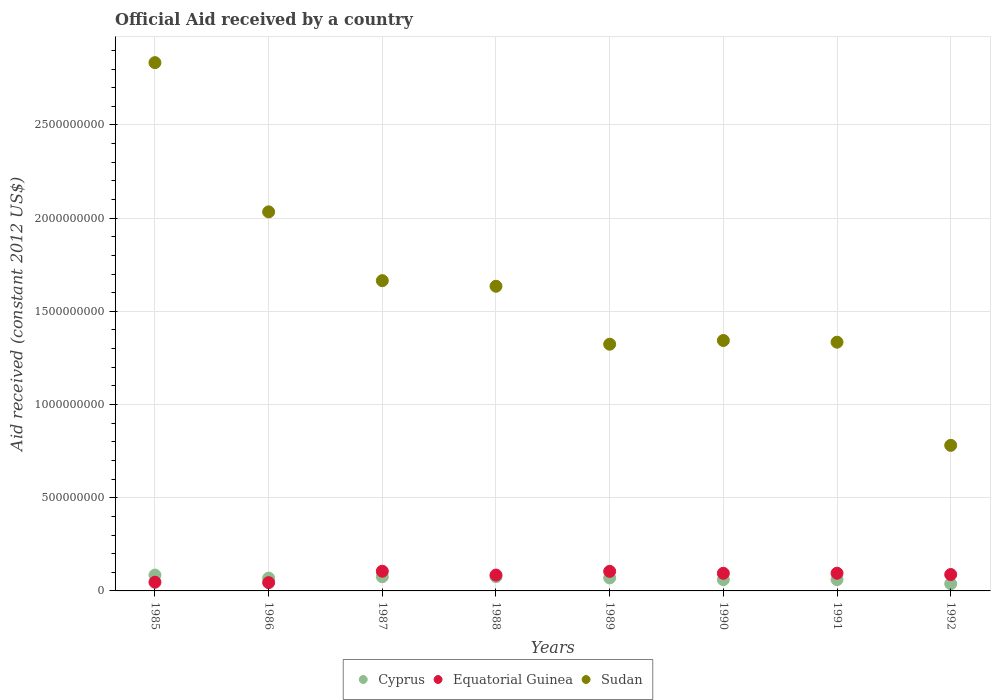What is the net official aid received in Sudan in 1989?
Give a very brief answer. 1.32e+09. Across all years, what is the maximum net official aid received in Equatorial Guinea?
Make the answer very short. 1.06e+08. Across all years, what is the minimum net official aid received in Equatorial Guinea?
Provide a short and direct response. 4.45e+07. In which year was the net official aid received in Cyprus maximum?
Your response must be concise. 1985. In which year was the net official aid received in Equatorial Guinea minimum?
Keep it short and to the point. 1986. What is the total net official aid received in Equatorial Guinea in the graph?
Give a very brief answer. 6.64e+08. What is the difference between the net official aid received in Cyprus in 1987 and that in 1992?
Provide a succinct answer. 3.78e+07. What is the difference between the net official aid received in Cyprus in 1985 and the net official aid received in Sudan in 1992?
Offer a very short reply. -6.96e+08. What is the average net official aid received in Equatorial Guinea per year?
Offer a terse response. 8.31e+07. In the year 1991, what is the difference between the net official aid received in Sudan and net official aid received in Cyprus?
Your response must be concise. 1.27e+09. In how many years, is the net official aid received in Equatorial Guinea greater than 100000000 US$?
Your answer should be very brief. 2. What is the ratio of the net official aid received in Sudan in 1989 to that in 1990?
Offer a terse response. 0.99. What is the difference between the highest and the second highest net official aid received in Equatorial Guinea?
Offer a terse response. 6.80e+05. What is the difference between the highest and the lowest net official aid received in Sudan?
Offer a very short reply. 2.05e+09. In how many years, is the net official aid received in Cyprus greater than the average net official aid received in Cyprus taken over all years?
Provide a succinct answer. 5. Is the sum of the net official aid received in Sudan in 1985 and 1992 greater than the maximum net official aid received in Cyprus across all years?
Your answer should be compact. Yes. Does the net official aid received in Sudan monotonically increase over the years?
Your response must be concise. No. Are the values on the major ticks of Y-axis written in scientific E-notation?
Your response must be concise. No. Does the graph contain any zero values?
Keep it short and to the point. No. Does the graph contain grids?
Your answer should be very brief. Yes. How many legend labels are there?
Offer a very short reply. 3. What is the title of the graph?
Give a very brief answer. Official Aid received by a country. Does "El Salvador" appear as one of the legend labels in the graph?
Offer a terse response. No. What is the label or title of the X-axis?
Keep it short and to the point. Years. What is the label or title of the Y-axis?
Your answer should be compact. Aid received (constant 2012 US$). What is the Aid received (constant 2012 US$) in Cyprus in 1985?
Provide a succinct answer. 8.49e+07. What is the Aid received (constant 2012 US$) of Equatorial Guinea in 1985?
Your response must be concise. 4.67e+07. What is the Aid received (constant 2012 US$) in Sudan in 1985?
Offer a very short reply. 2.83e+09. What is the Aid received (constant 2012 US$) of Cyprus in 1986?
Provide a succinct answer. 6.87e+07. What is the Aid received (constant 2012 US$) of Equatorial Guinea in 1986?
Your response must be concise. 4.45e+07. What is the Aid received (constant 2012 US$) in Sudan in 1986?
Make the answer very short. 2.03e+09. What is the Aid received (constant 2012 US$) of Cyprus in 1987?
Provide a short and direct response. 7.61e+07. What is the Aid received (constant 2012 US$) of Equatorial Guinea in 1987?
Ensure brevity in your answer.  1.06e+08. What is the Aid received (constant 2012 US$) of Sudan in 1987?
Make the answer very short. 1.66e+09. What is the Aid received (constant 2012 US$) of Cyprus in 1988?
Your answer should be very brief. 7.65e+07. What is the Aid received (constant 2012 US$) in Equatorial Guinea in 1988?
Provide a short and direct response. 8.51e+07. What is the Aid received (constant 2012 US$) of Sudan in 1988?
Make the answer very short. 1.63e+09. What is the Aid received (constant 2012 US$) of Cyprus in 1989?
Provide a succinct answer. 6.97e+07. What is the Aid received (constant 2012 US$) in Equatorial Guinea in 1989?
Ensure brevity in your answer.  1.05e+08. What is the Aid received (constant 2012 US$) of Sudan in 1989?
Provide a short and direct response. 1.32e+09. What is the Aid received (constant 2012 US$) in Cyprus in 1990?
Your answer should be compact. 6.04e+07. What is the Aid received (constant 2012 US$) in Equatorial Guinea in 1990?
Offer a very short reply. 9.45e+07. What is the Aid received (constant 2012 US$) in Sudan in 1990?
Your response must be concise. 1.34e+09. What is the Aid received (constant 2012 US$) of Cyprus in 1991?
Provide a succinct answer. 6.07e+07. What is the Aid received (constant 2012 US$) of Equatorial Guinea in 1991?
Make the answer very short. 9.50e+07. What is the Aid received (constant 2012 US$) in Sudan in 1991?
Your response must be concise. 1.33e+09. What is the Aid received (constant 2012 US$) of Cyprus in 1992?
Offer a very short reply. 3.83e+07. What is the Aid received (constant 2012 US$) of Equatorial Guinea in 1992?
Provide a short and direct response. 8.80e+07. What is the Aid received (constant 2012 US$) of Sudan in 1992?
Provide a short and direct response. 7.81e+08. Across all years, what is the maximum Aid received (constant 2012 US$) of Cyprus?
Your answer should be very brief. 8.49e+07. Across all years, what is the maximum Aid received (constant 2012 US$) of Equatorial Guinea?
Provide a succinct answer. 1.06e+08. Across all years, what is the maximum Aid received (constant 2012 US$) in Sudan?
Provide a succinct answer. 2.83e+09. Across all years, what is the minimum Aid received (constant 2012 US$) of Cyprus?
Provide a succinct answer. 3.83e+07. Across all years, what is the minimum Aid received (constant 2012 US$) of Equatorial Guinea?
Make the answer very short. 4.45e+07. Across all years, what is the minimum Aid received (constant 2012 US$) of Sudan?
Provide a short and direct response. 7.81e+08. What is the total Aid received (constant 2012 US$) in Cyprus in the graph?
Your answer should be very brief. 5.35e+08. What is the total Aid received (constant 2012 US$) in Equatorial Guinea in the graph?
Provide a short and direct response. 6.64e+08. What is the total Aid received (constant 2012 US$) of Sudan in the graph?
Make the answer very short. 1.30e+1. What is the difference between the Aid received (constant 2012 US$) in Cyprus in 1985 and that in 1986?
Your answer should be very brief. 1.62e+07. What is the difference between the Aid received (constant 2012 US$) of Equatorial Guinea in 1985 and that in 1986?
Ensure brevity in your answer.  2.23e+06. What is the difference between the Aid received (constant 2012 US$) of Sudan in 1985 and that in 1986?
Your answer should be compact. 8.01e+08. What is the difference between the Aid received (constant 2012 US$) in Cyprus in 1985 and that in 1987?
Make the answer very short. 8.87e+06. What is the difference between the Aid received (constant 2012 US$) in Equatorial Guinea in 1985 and that in 1987?
Offer a very short reply. -5.89e+07. What is the difference between the Aid received (constant 2012 US$) in Sudan in 1985 and that in 1987?
Your answer should be very brief. 1.17e+09. What is the difference between the Aid received (constant 2012 US$) in Cyprus in 1985 and that in 1988?
Offer a very short reply. 8.47e+06. What is the difference between the Aid received (constant 2012 US$) of Equatorial Guinea in 1985 and that in 1988?
Give a very brief answer. -3.84e+07. What is the difference between the Aid received (constant 2012 US$) in Sudan in 1985 and that in 1988?
Make the answer very short. 1.20e+09. What is the difference between the Aid received (constant 2012 US$) in Cyprus in 1985 and that in 1989?
Your answer should be very brief. 1.52e+07. What is the difference between the Aid received (constant 2012 US$) in Equatorial Guinea in 1985 and that in 1989?
Provide a short and direct response. -5.82e+07. What is the difference between the Aid received (constant 2012 US$) in Sudan in 1985 and that in 1989?
Keep it short and to the point. 1.51e+09. What is the difference between the Aid received (constant 2012 US$) of Cyprus in 1985 and that in 1990?
Your answer should be very brief. 2.46e+07. What is the difference between the Aid received (constant 2012 US$) in Equatorial Guinea in 1985 and that in 1990?
Keep it short and to the point. -4.78e+07. What is the difference between the Aid received (constant 2012 US$) in Sudan in 1985 and that in 1990?
Provide a short and direct response. 1.49e+09. What is the difference between the Aid received (constant 2012 US$) of Cyprus in 1985 and that in 1991?
Offer a very short reply. 2.42e+07. What is the difference between the Aid received (constant 2012 US$) in Equatorial Guinea in 1985 and that in 1991?
Provide a succinct answer. -4.83e+07. What is the difference between the Aid received (constant 2012 US$) of Sudan in 1985 and that in 1991?
Provide a short and direct response. 1.50e+09. What is the difference between the Aid received (constant 2012 US$) of Cyprus in 1985 and that in 1992?
Keep it short and to the point. 4.67e+07. What is the difference between the Aid received (constant 2012 US$) of Equatorial Guinea in 1985 and that in 1992?
Your answer should be compact. -4.13e+07. What is the difference between the Aid received (constant 2012 US$) in Sudan in 1985 and that in 1992?
Ensure brevity in your answer.  2.05e+09. What is the difference between the Aid received (constant 2012 US$) of Cyprus in 1986 and that in 1987?
Your answer should be compact. -7.34e+06. What is the difference between the Aid received (constant 2012 US$) in Equatorial Guinea in 1986 and that in 1987?
Keep it short and to the point. -6.11e+07. What is the difference between the Aid received (constant 2012 US$) in Sudan in 1986 and that in 1987?
Offer a very short reply. 3.69e+08. What is the difference between the Aid received (constant 2012 US$) in Cyprus in 1986 and that in 1988?
Your answer should be very brief. -7.74e+06. What is the difference between the Aid received (constant 2012 US$) of Equatorial Guinea in 1986 and that in 1988?
Provide a short and direct response. -4.06e+07. What is the difference between the Aid received (constant 2012 US$) of Sudan in 1986 and that in 1988?
Your response must be concise. 3.99e+08. What is the difference between the Aid received (constant 2012 US$) of Cyprus in 1986 and that in 1989?
Offer a very short reply. -9.90e+05. What is the difference between the Aid received (constant 2012 US$) of Equatorial Guinea in 1986 and that in 1989?
Keep it short and to the point. -6.05e+07. What is the difference between the Aid received (constant 2012 US$) in Sudan in 1986 and that in 1989?
Keep it short and to the point. 7.10e+08. What is the difference between the Aid received (constant 2012 US$) of Cyprus in 1986 and that in 1990?
Ensure brevity in your answer.  8.35e+06. What is the difference between the Aid received (constant 2012 US$) in Equatorial Guinea in 1986 and that in 1990?
Give a very brief answer. -5.00e+07. What is the difference between the Aid received (constant 2012 US$) in Sudan in 1986 and that in 1990?
Your answer should be compact. 6.90e+08. What is the difference between the Aid received (constant 2012 US$) of Cyprus in 1986 and that in 1991?
Ensure brevity in your answer.  8.02e+06. What is the difference between the Aid received (constant 2012 US$) of Equatorial Guinea in 1986 and that in 1991?
Your answer should be compact. -5.05e+07. What is the difference between the Aid received (constant 2012 US$) of Sudan in 1986 and that in 1991?
Your answer should be compact. 6.99e+08. What is the difference between the Aid received (constant 2012 US$) in Cyprus in 1986 and that in 1992?
Your response must be concise. 3.05e+07. What is the difference between the Aid received (constant 2012 US$) of Equatorial Guinea in 1986 and that in 1992?
Your response must be concise. -4.35e+07. What is the difference between the Aid received (constant 2012 US$) of Sudan in 1986 and that in 1992?
Provide a succinct answer. 1.25e+09. What is the difference between the Aid received (constant 2012 US$) in Cyprus in 1987 and that in 1988?
Ensure brevity in your answer.  -4.00e+05. What is the difference between the Aid received (constant 2012 US$) in Equatorial Guinea in 1987 and that in 1988?
Ensure brevity in your answer.  2.05e+07. What is the difference between the Aid received (constant 2012 US$) of Sudan in 1987 and that in 1988?
Provide a short and direct response. 3.00e+07. What is the difference between the Aid received (constant 2012 US$) in Cyprus in 1987 and that in 1989?
Offer a very short reply. 6.35e+06. What is the difference between the Aid received (constant 2012 US$) in Equatorial Guinea in 1987 and that in 1989?
Your response must be concise. 6.80e+05. What is the difference between the Aid received (constant 2012 US$) of Sudan in 1987 and that in 1989?
Make the answer very short. 3.41e+08. What is the difference between the Aid received (constant 2012 US$) of Cyprus in 1987 and that in 1990?
Provide a succinct answer. 1.57e+07. What is the difference between the Aid received (constant 2012 US$) in Equatorial Guinea in 1987 and that in 1990?
Provide a short and direct response. 1.11e+07. What is the difference between the Aid received (constant 2012 US$) in Sudan in 1987 and that in 1990?
Provide a short and direct response. 3.21e+08. What is the difference between the Aid received (constant 2012 US$) of Cyprus in 1987 and that in 1991?
Your answer should be compact. 1.54e+07. What is the difference between the Aid received (constant 2012 US$) of Equatorial Guinea in 1987 and that in 1991?
Provide a short and direct response. 1.06e+07. What is the difference between the Aid received (constant 2012 US$) in Sudan in 1987 and that in 1991?
Offer a very short reply. 3.30e+08. What is the difference between the Aid received (constant 2012 US$) of Cyprus in 1987 and that in 1992?
Offer a terse response. 3.78e+07. What is the difference between the Aid received (constant 2012 US$) of Equatorial Guinea in 1987 and that in 1992?
Offer a terse response. 1.76e+07. What is the difference between the Aid received (constant 2012 US$) of Sudan in 1987 and that in 1992?
Your answer should be very brief. 8.84e+08. What is the difference between the Aid received (constant 2012 US$) in Cyprus in 1988 and that in 1989?
Offer a terse response. 6.75e+06. What is the difference between the Aid received (constant 2012 US$) of Equatorial Guinea in 1988 and that in 1989?
Offer a terse response. -1.98e+07. What is the difference between the Aid received (constant 2012 US$) of Sudan in 1988 and that in 1989?
Provide a short and direct response. 3.11e+08. What is the difference between the Aid received (constant 2012 US$) of Cyprus in 1988 and that in 1990?
Give a very brief answer. 1.61e+07. What is the difference between the Aid received (constant 2012 US$) in Equatorial Guinea in 1988 and that in 1990?
Offer a terse response. -9.40e+06. What is the difference between the Aid received (constant 2012 US$) of Sudan in 1988 and that in 1990?
Make the answer very short. 2.91e+08. What is the difference between the Aid received (constant 2012 US$) of Cyprus in 1988 and that in 1991?
Provide a succinct answer. 1.58e+07. What is the difference between the Aid received (constant 2012 US$) of Equatorial Guinea in 1988 and that in 1991?
Make the answer very short. -9.92e+06. What is the difference between the Aid received (constant 2012 US$) in Sudan in 1988 and that in 1991?
Your answer should be compact. 3.00e+08. What is the difference between the Aid received (constant 2012 US$) of Cyprus in 1988 and that in 1992?
Make the answer very short. 3.82e+07. What is the difference between the Aid received (constant 2012 US$) in Equatorial Guinea in 1988 and that in 1992?
Give a very brief answer. -2.87e+06. What is the difference between the Aid received (constant 2012 US$) in Sudan in 1988 and that in 1992?
Your response must be concise. 8.54e+08. What is the difference between the Aid received (constant 2012 US$) in Cyprus in 1989 and that in 1990?
Offer a terse response. 9.34e+06. What is the difference between the Aid received (constant 2012 US$) of Equatorial Guinea in 1989 and that in 1990?
Ensure brevity in your answer.  1.04e+07. What is the difference between the Aid received (constant 2012 US$) in Sudan in 1989 and that in 1990?
Your answer should be compact. -2.00e+07. What is the difference between the Aid received (constant 2012 US$) in Cyprus in 1989 and that in 1991?
Give a very brief answer. 9.01e+06. What is the difference between the Aid received (constant 2012 US$) of Equatorial Guinea in 1989 and that in 1991?
Give a very brief answer. 9.92e+06. What is the difference between the Aid received (constant 2012 US$) of Sudan in 1989 and that in 1991?
Offer a terse response. -1.09e+07. What is the difference between the Aid received (constant 2012 US$) in Cyprus in 1989 and that in 1992?
Give a very brief answer. 3.14e+07. What is the difference between the Aid received (constant 2012 US$) of Equatorial Guinea in 1989 and that in 1992?
Your response must be concise. 1.70e+07. What is the difference between the Aid received (constant 2012 US$) in Sudan in 1989 and that in 1992?
Your answer should be very brief. 5.43e+08. What is the difference between the Aid received (constant 2012 US$) of Cyprus in 1990 and that in 1991?
Offer a very short reply. -3.30e+05. What is the difference between the Aid received (constant 2012 US$) in Equatorial Guinea in 1990 and that in 1991?
Your response must be concise. -5.20e+05. What is the difference between the Aid received (constant 2012 US$) in Sudan in 1990 and that in 1991?
Provide a succinct answer. 9.13e+06. What is the difference between the Aid received (constant 2012 US$) of Cyprus in 1990 and that in 1992?
Offer a very short reply. 2.21e+07. What is the difference between the Aid received (constant 2012 US$) in Equatorial Guinea in 1990 and that in 1992?
Your answer should be compact. 6.53e+06. What is the difference between the Aid received (constant 2012 US$) of Sudan in 1990 and that in 1992?
Your response must be concise. 5.63e+08. What is the difference between the Aid received (constant 2012 US$) in Cyprus in 1991 and that in 1992?
Offer a very short reply. 2.24e+07. What is the difference between the Aid received (constant 2012 US$) in Equatorial Guinea in 1991 and that in 1992?
Offer a very short reply. 7.05e+06. What is the difference between the Aid received (constant 2012 US$) in Sudan in 1991 and that in 1992?
Offer a terse response. 5.53e+08. What is the difference between the Aid received (constant 2012 US$) of Cyprus in 1985 and the Aid received (constant 2012 US$) of Equatorial Guinea in 1986?
Your answer should be compact. 4.04e+07. What is the difference between the Aid received (constant 2012 US$) of Cyprus in 1985 and the Aid received (constant 2012 US$) of Sudan in 1986?
Your answer should be compact. -1.95e+09. What is the difference between the Aid received (constant 2012 US$) in Equatorial Guinea in 1985 and the Aid received (constant 2012 US$) in Sudan in 1986?
Give a very brief answer. -1.99e+09. What is the difference between the Aid received (constant 2012 US$) in Cyprus in 1985 and the Aid received (constant 2012 US$) in Equatorial Guinea in 1987?
Ensure brevity in your answer.  -2.07e+07. What is the difference between the Aid received (constant 2012 US$) in Cyprus in 1985 and the Aid received (constant 2012 US$) in Sudan in 1987?
Your answer should be compact. -1.58e+09. What is the difference between the Aid received (constant 2012 US$) in Equatorial Guinea in 1985 and the Aid received (constant 2012 US$) in Sudan in 1987?
Keep it short and to the point. -1.62e+09. What is the difference between the Aid received (constant 2012 US$) of Cyprus in 1985 and the Aid received (constant 2012 US$) of Equatorial Guinea in 1988?
Your answer should be very brief. -1.80e+05. What is the difference between the Aid received (constant 2012 US$) in Cyprus in 1985 and the Aid received (constant 2012 US$) in Sudan in 1988?
Keep it short and to the point. -1.55e+09. What is the difference between the Aid received (constant 2012 US$) of Equatorial Guinea in 1985 and the Aid received (constant 2012 US$) of Sudan in 1988?
Offer a very short reply. -1.59e+09. What is the difference between the Aid received (constant 2012 US$) in Cyprus in 1985 and the Aid received (constant 2012 US$) in Equatorial Guinea in 1989?
Your answer should be very brief. -2.00e+07. What is the difference between the Aid received (constant 2012 US$) in Cyprus in 1985 and the Aid received (constant 2012 US$) in Sudan in 1989?
Your answer should be very brief. -1.24e+09. What is the difference between the Aid received (constant 2012 US$) in Equatorial Guinea in 1985 and the Aid received (constant 2012 US$) in Sudan in 1989?
Provide a short and direct response. -1.28e+09. What is the difference between the Aid received (constant 2012 US$) of Cyprus in 1985 and the Aid received (constant 2012 US$) of Equatorial Guinea in 1990?
Your response must be concise. -9.58e+06. What is the difference between the Aid received (constant 2012 US$) in Cyprus in 1985 and the Aid received (constant 2012 US$) in Sudan in 1990?
Your response must be concise. -1.26e+09. What is the difference between the Aid received (constant 2012 US$) in Equatorial Guinea in 1985 and the Aid received (constant 2012 US$) in Sudan in 1990?
Make the answer very short. -1.30e+09. What is the difference between the Aid received (constant 2012 US$) of Cyprus in 1985 and the Aid received (constant 2012 US$) of Equatorial Guinea in 1991?
Ensure brevity in your answer.  -1.01e+07. What is the difference between the Aid received (constant 2012 US$) of Cyprus in 1985 and the Aid received (constant 2012 US$) of Sudan in 1991?
Provide a short and direct response. -1.25e+09. What is the difference between the Aid received (constant 2012 US$) in Equatorial Guinea in 1985 and the Aid received (constant 2012 US$) in Sudan in 1991?
Give a very brief answer. -1.29e+09. What is the difference between the Aid received (constant 2012 US$) of Cyprus in 1985 and the Aid received (constant 2012 US$) of Equatorial Guinea in 1992?
Provide a short and direct response. -3.05e+06. What is the difference between the Aid received (constant 2012 US$) in Cyprus in 1985 and the Aid received (constant 2012 US$) in Sudan in 1992?
Your answer should be very brief. -6.96e+08. What is the difference between the Aid received (constant 2012 US$) of Equatorial Guinea in 1985 and the Aid received (constant 2012 US$) of Sudan in 1992?
Offer a very short reply. -7.34e+08. What is the difference between the Aid received (constant 2012 US$) in Cyprus in 1986 and the Aid received (constant 2012 US$) in Equatorial Guinea in 1987?
Ensure brevity in your answer.  -3.69e+07. What is the difference between the Aid received (constant 2012 US$) of Cyprus in 1986 and the Aid received (constant 2012 US$) of Sudan in 1987?
Provide a short and direct response. -1.60e+09. What is the difference between the Aid received (constant 2012 US$) in Equatorial Guinea in 1986 and the Aid received (constant 2012 US$) in Sudan in 1987?
Your answer should be very brief. -1.62e+09. What is the difference between the Aid received (constant 2012 US$) of Cyprus in 1986 and the Aid received (constant 2012 US$) of Equatorial Guinea in 1988?
Your answer should be compact. -1.64e+07. What is the difference between the Aid received (constant 2012 US$) in Cyprus in 1986 and the Aid received (constant 2012 US$) in Sudan in 1988?
Offer a very short reply. -1.57e+09. What is the difference between the Aid received (constant 2012 US$) in Equatorial Guinea in 1986 and the Aid received (constant 2012 US$) in Sudan in 1988?
Offer a very short reply. -1.59e+09. What is the difference between the Aid received (constant 2012 US$) of Cyprus in 1986 and the Aid received (constant 2012 US$) of Equatorial Guinea in 1989?
Your answer should be compact. -3.62e+07. What is the difference between the Aid received (constant 2012 US$) in Cyprus in 1986 and the Aid received (constant 2012 US$) in Sudan in 1989?
Ensure brevity in your answer.  -1.25e+09. What is the difference between the Aid received (constant 2012 US$) of Equatorial Guinea in 1986 and the Aid received (constant 2012 US$) of Sudan in 1989?
Make the answer very short. -1.28e+09. What is the difference between the Aid received (constant 2012 US$) of Cyprus in 1986 and the Aid received (constant 2012 US$) of Equatorial Guinea in 1990?
Give a very brief answer. -2.58e+07. What is the difference between the Aid received (constant 2012 US$) of Cyprus in 1986 and the Aid received (constant 2012 US$) of Sudan in 1990?
Provide a short and direct response. -1.27e+09. What is the difference between the Aid received (constant 2012 US$) of Equatorial Guinea in 1986 and the Aid received (constant 2012 US$) of Sudan in 1990?
Ensure brevity in your answer.  -1.30e+09. What is the difference between the Aid received (constant 2012 US$) in Cyprus in 1986 and the Aid received (constant 2012 US$) in Equatorial Guinea in 1991?
Make the answer very short. -2.63e+07. What is the difference between the Aid received (constant 2012 US$) of Cyprus in 1986 and the Aid received (constant 2012 US$) of Sudan in 1991?
Make the answer very short. -1.27e+09. What is the difference between the Aid received (constant 2012 US$) of Equatorial Guinea in 1986 and the Aid received (constant 2012 US$) of Sudan in 1991?
Your answer should be very brief. -1.29e+09. What is the difference between the Aid received (constant 2012 US$) in Cyprus in 1986 and the Aid received (constant 2012 US$) in Equatorial Guinea in 1992?
Provide a short and direct response. -1.93e+07. What is the difference between the Aid received (constant 2012 US$) in Cyprus in 1986 and the Aid received (constant 2012 US$) in Sudan in 1992?
Give a very brief answer. -7.12e+08. What is the difference between the Aid received (constant 2012 US$) of Equatorial Guinea in 1986 and the Aid received (constant 2012 US$) of Sudan in 1992?
Your answer should be compact. -7.37e+08. What is the difference between the Aid received (constant 2012 US$) of Cyprus in 1987 and the Aid received (constant 2012 US$) of Equatorial Guinea in 1988?
Keep it short and to the point. -9.05e+06. What is the difference between the Aid received (constant 2012 US$) of Cyprus in 1987 and the Aid received (constant 2012 US$) of Sudan in 1988?
Give a very brief answer. -1.56e+09. What is the difference between the Aid received (constant 2012 US$) in Equatorial Guinea in 1987 and the Aid received (constant 2012 US$) in Sudan in 1988?
Keep it short and to the point. -1.53e+09. What is the difference between the Aid received (constant 2012 US$) of Cyprus in 1987 and the Aid received (constant 2012 US$) of Equatorial Guinea in 1989?
Make the answer very short. -2.89e+07. What is the difference between the Aid received (constant 2012 US$) of Cyprus in 1987 and the Aid received (constant 2012 US$) of Sudan in 1989?
Keep it short and to the point. -1.25e+09. What is the difference between the Aid received (constant 2012 US$) in Equatorial Guinea in 1987 and the Aid received (constant 2012 US$) in Sudan in 1989?
Make the answer very short. -1.22e+09. What is the difference between the Aid received (constant 2012 US$) in Cyprus in 1987 and the Aid received (constant 2012 US$) in Equatorial Guinea in 1990?
Your response must be concise. -1.84e+07. What is the difference between the Aid received (constant 2012 US$) in Cyprus in 1987 and the Aid received (constant 2012 US$) in Sudan in 1990?
Provide a succinct answer. -1.27e+09. What is the difference between the Aid received (constant 2012 US$) of Equatorial Guinea in 1987 and the Aid received (constant 2012 US$) of Sudan in 1990?
Your response must be concise. -1.24e+09. What is the difference between the Aid received (constant 2012 US$) in Cyprus in 1987 and the Aid received (constant 2012 US$) in Equatorial Guinea in 1991?
Your answer should be compact. -1.90e+07. What is the difference between the Aid received (constant 2012 US$) of Cyprus in 1987 and the Aid received (constant 2012 US$) of Sudan in 1991?
Make the answer very short. -1.26e+09. What is the difference between the Aid received (constant 2012 US$) in Equatorial Guinea in 1987 and the Aid received (constant 2012 US$) in Sudan in 1991?
Give a very brief answer. -1.23e+09. What is the difference between the Aid received (constant 2012 US$) in Cyprus in 1987 and the Aid received (constant 2012 US$) in Equatorial Guinea in 1992?
Your answer should be compact. -1.19e+07. What is the difference between the Aid received (constant 2012 US$) in Cyprus in 1987 and the Aid received (constant 2012 US$) in Sudan in 1992?
Keep it short and to the point. -7.05e+08. What is the difference between the Aid received (constant 2012 US$) of Equatorial Guinea in 1987 and the Aid received (constant 2012 US$) of Sudan in 1992?
Provide a succinct answer. -6.75e+08. What is the difference between the Aid received (constant 2012 US$) of Cyprus in 1988 and the Aid received (constant 2012 US$) of Equatorial Guinea in 1989?
Provide a succinct answer. -2.85e+07. What is the difference between the Aid received (constant 2012 US$) in Cyprus in 1988 and the Aid received (constant 2012 US$) in Sudan in 1989?
Provide a short and direct response. -1.25e+09. What is the difference between the Aid received (constant 2012 US$) in Equatorial Guinea in 1988 and the Aid received (constant 2012 US$) in Sudan in 1989?
Make the answer very short. -1.24e+09. What is the difference between the Aid received (constant 2012 US$) of Cyprus in 1988 and the Aid received (constant 2012 US$) of Equatorial Guinea in 1990?
Offer a terse response. -1.80e+07. What is the difference between the Aid received (constant 2012 US$) of Cyprus in 1988 and the Aid received (constant 2012 US$) of Sudan in 1990?
Keep it short and to the point. -1.27e+09. What is the difference between the Aid received (constant 2012 US$) of Equatorial Guinea in 1988 and the Aid received (constant 2012 US$) of Sudan in 1990?
Offer a terse response. -1.26e+09. What is the difference between the Aid received (constant 2012 US$) of Cyprus in 1988 and the Aid received (constant 2012 US$) of Equatorial Guinea in 1991?
Your response must be concise. -1.86e+07. What is the difference between the Aid received (constant 2012 US$) in Cyprus in 1988 and the Aid received (constant 2012 US$) in Sudan in 1991?
Offer a terse response. -1.26e+09. What is the difference between the Aid received (constant 2012 US$) of Equatorial Guinea in 1988 and the Aid received (constant 2012 US$) of Sudan in 1991?
Keep it short and to the point. -1.25e+09. What is the difference between the Aid received (constant 2012 US$) of Cyprus in 1988 and the Aid received (constant 2012 US$) of Equatorial Guinea in 1992?
Ensure brevity in your answer.  -1.15e+07. What is the difference between the Aid received (constant 2012 US$) of Cyprus in 1988 and the Aid received (constant 2012 US$) of Sudan in 1992?
Your answer should be compact. -7.05e+08. What is the difference between the Aid received (constant 2012 US$) of Equatorial Guinea in 1988 and the Aid received (constant 2012 US$) of Sudan in 1992?
Your response must be concise. -6.96e+08. What is the difference between the Aid received (constant 2012 US$) in Cyprus in 1989 and the Aid received (constant 2012 US$) in Equatorial Guinea in 1990?
Your answer should be compact. -2.48e+07. What is the difference between the Aid received (constant 2012 US$) of Cyprus in 1989 and the Aid received (constant 2012 US$) of Sudan in 1990?
Your answer should be very brief. -1.27e+09. What is the difference between the Aid received (constant 2012 US$) of Equatorial Guinea in 1989 and the Aid received (constant 2012 US$) of Sudan in 1990?
Your response must be concise. -1.24e+09. What is the difference between the Aid received (constant 2012 US$) of Cyprus in 1989 and the Aid received (constant 2012 US$) of Equatorial Guinea in 1991?
Offer a terse response. -2.53e+07. What is the difference between the Aid received (constant 2012 US$) of Cyprus in 1989 and the Aid received (constant 2012 US$) of Sudan in 1991?
Offer a very short reply. -1.26e+09. What is the difference between the Aid received (constant 2012 US$) of Equatorial Guinea in 1989 and the Aid received (constant 2012 US$) of Sudan in 1991?
Ensure brevity in your answer.  -1.23e+09. What is the difference between the Aid received (constant 2012 US$) in Cyprus in 1989 and the Aid received (constant 2012 US$) in Equatorial Guinea in 1992?
Provide a short and direct response. -1.83e+07. What is the difference between the Aid received (constant 2012 US$) of Cyprus in 1989 and the Aid received (constant 2012 US$) of Sudan in 1992?
Ensure brevity in your answer.  -7.11e+08. What is the difference between the Aid received (constant 2012 US$) in Equatorial Guinea in 1989 and the Aid received (constant 2012 US$) in Sudan in 1992?
Your answer should be very brief. -6.76e+08. What is the difference between the Aid received (constant 2012 US$) of Cyprus in 1990 and the Aid received (constant 2012 US$) of Equatorial Guinea in 1991?
Offer a very short reply. -3.47e+07. What is the difference between the Aid received (constant 2012 US$) of Cyprus in 1990 and the Aid received (constant 2012 US$) of Sudan in 1991?
Provide a succinct answer. -1.27e+09. What is the difference between the Aid received (constant 2012 US$) in Equatorial Guinea in 1990 and the Aid received (constant 2012 US$) in Sudan in 1991?
Make the answer very short. -1.24e+09. What is the difference between the Aid received (constant 2012 US$) of Cyprus in 1990 and the Aid received (constant 2012 US$) of Equatorial Guinea in 1992?
Provide a succinct answer. -2.76e+07. What is the difference between the Aid received (constant 2012 US$) of Cyprus in 1990 and the Aid received (constant 2012 US$) of Sudan in 1992?
Offer a very short reply. -7.21e+08. What is the difference between the Aid received (constant 2012 US$) of Equatorial Guinea in 1990 and the Aid received (constant 2012 US$) of Sudan in 1992?
Give a very brief answer. -6.86e+08. What is the difference between the Aid received (constant 2012 US$) of Cyprus in 1991 and the Aid received (constant 2012 US$) of Equatorial Guinea in 1992?
Offer a very short reply. -2.73e+07. What is the difference between the Aid received (constant 2012 US$) in Cyprus in 1991 and the Aid received (constant 2012 US$) in Sudan in 1992?
Make the answer very short. -7.20e+08. What is the difference between the Aid received (constant 2012 US$) in Equatorial Guinea in 1991 and the Aid received (constant 2012 US$) in Sudan in 1992?
Give a very brief answer. -6.86e+08. What is the average Aid received (constant 2012 US$) in Cyprus per year?
Your answer should be very brief. 6.69e+07. What is the average Aid received (constant 2012 US$) in Equatorial Guinea per year?
Your response must be concise. 8.31e+07. What is the average Aid received (constant 2012 US$) in Sudan per year?
Ensure brevity in your answer.  1.62e+09. In the year 1985, what is the difference between the Aid received (constant 2012 US$) in Cyprus and Aid received (constant 2012 US$) in Equatorial Guinea?
Ensure brevity in your answer.  3.82e+07. In the year 1985, what is the difference between the Aid received (constant 2012 US$) of Cyprus and Aid received (constant 2012 US$) of Sudan?
Give a very brief answer. -2.75e+09. In the year 1985, what is the difference between the Aid received (constant 2012 US$) of Equatorial Guinea and Aid received (constant 2012 US$) of Sudan?
Give a very brief answer. -2.79e+09. In the year 1986, what is the difference between the Aid received (constant 2012 US$) of Cyprus and Aid received (constant 2012 US$) of Equatorial Guinea?
Keep it short and to the point. 2.42e+07. In the year 1986, what is the difference between the Aid received (constant 2012 US$) of Cyprus and Aid received (constant 2012 US$) of Sudan?
Offer a very short reply. -1.97e+09. In the year 1986, what is the difference between the Aid received (constant 2012 US$) of Equatorial Guinea and Aid received (constant 2012 US$) of Sudan?
Offer a very short reply. -1.99e+09. In the year 1987, what is the difference between the Aid received (constant 2012 US$) of Cyprus and Aid received (constant 2012 US$) of Equatorial Guinea?
Your response must be concise. -2.96e+07. In the year 1987, what is the difference between the Aid received (constant 2012 US$) in Cyprus and Aid received (constant 2012 US$) in Sudan?
Your response must be concise. -1.59e+09. In the year 1987, what is the difference between the Aid received (constant 2012 US$) of Equatorial Guinea and Aid received (constant 2012 US$) of Sudan?
Your answer should be compact. -1.56e+09. In the year 1988, what is the difference between the Aid received (constant 2012 US$) of Cyprus and Aid received (constant 2012 US$) of Equatorial Guinea?
Provide a short and direct response. -8.65e+06. In the year 1988, what is the difference between the Aid received (constant 2012 US$) in Cyprus and Aid received (constant 2012 US$) in Sudan?
Offer a terse response. -1.56e+09. In the year 1988, what is the difference between the Aid received (constant 2012 US$) of Equatorial Guinea and Aid received (constant 2012 US$) of Sudan?
Offer a very short reply. -1.55e+09. In the year 1989, what is the difference between the Aid received (constant 2012 US$) of Cyprus and Aid received (constant 2012 US$) of Equatorial Guinea?
Offer a very short reply. -3.52e+07. In the year 1989, what is the difference between the Aid received (constant 2012 US$) in Cyprus and Aid received (constant 2012 US$) in Sudan?
Your answer should be compact. -1.25e+09. In the year 1989, what is the difference between the Aid received (constant 2012 US$) of Equatorial Guinea and Aid received (constant 2012 US$) of Sudan?
Give a very brief answer. -1.22e+09. In the year 1990, what is the difference between the Aid received (constant 2012 US$) in Cyprus and Aid received (constant 2012 US$) in Equatorial Guinea?
Provide a short and direct response. -3.41e+07. In the year 1990, what is the difference between the Aid received (constant 2012 US$) of Cyprus and Aid received (constant 2012 US$) of Sudan?
Your answer should be very brief. -1.28e+09. In the year 1990, what is the difference between the Aid received (constant 2012 US$) in Equatorial Guinea and Aid received (constant 2012 US$) in Sudan?
Make the answer very short. -1.25e+09. In the year 1991, what is the difference between the Aid received (constant 2012 US$) of Cyprus and Aid received (constant 2012 US$) of Equatorial Guinea?
Your answer should be compact. -3.43e+07. In the year 1991, what is the difference between the Aid received (constant 2012 US$) of Cyprus and Aid received (constant 2012 US$) of Sudan?
Make the answer very short. -1.27e+09. In the year 1991, what is the difference between the Aid received (constant 2012 US$) in Equatorial Guinea and Aid received (constant 2012 US$) in Sudan?
Offer a terse response. -1.24e+09. In the year 1992, what is the difference between the Aid received (constant 2012 US$) in Cyprus and Aid received (constant 2012 US$) in Equatorial Guinea?
Make the answer very short. -4.97e+07. In the year 1992, what is the difference between the Aid received (constant 2012 US$) in Cyprus and Aid received (constant 2012 US$) in Sudan?
Keep it short and to the point. -7.43e+08. In the year 1992, what is the difference between the Aid received (constant 2012 US$) in Equatorial Guinea and Aid received (constant 2012 US$) in Sudan?
Offer a terse response. -6.93e+08. What is the ratio of the Aid received (constant 2012 US$) of Cyprus in 1985 to that in 1986?
Keep it short and to the point. 1.24. What is the ratio of the Aid received (constant 2012 US$) in Equatorial Guinea in 1985 to that in 1986?
Offer a terse response. 1.05. What is the ratio of the Aid received (constant 2012 US$) of Sudan in 1985 to that in 1986?
Your response must be concise. 1.39. What is the ratio of the Aid received (constant 2012 US$) of Cyprus in 1985 to that in 1987?
Ensure brevity in your answer.  1.12. What is the ratio of the Aid received (constant 2012 US$) in Equatorial Guinea in 1985 to that in 1987?
Keep it short and to the point. 0.44. What is the ratio of the Aid received (constant 2012 US$) of Sudan in 1985 to that in 1987?
Offer a terse response. 1.7. What is the ratio of the Aid received (constant 2012 US$) of Cyprus in 1985 to that in 1988?
Offer a very short reply. 1.11. What is the ratio of the Aid received (constant 2012 US$) in Equatorial Guinea in 1985 to that in 1988?
Keep it short and to the point. 0.55. What is the ratio of the Aid received (constant 2012 US$) in Sudan in 1985 to that in 1988?
Give a very brief answer. 1.73. What is the ratio of the Aid received (constant 2012 US$) of Cyprus in 1985 to that in 1989?
Keep it short and to the point. 1.22. What is the ratio of the Aid received (constant 2012 US$) in Equatorial Guinea in 1985 to that in 1989?
Ensure brevity in your answer.  0.45. What is the ratio of the Aid received (constant 2012 US$) in Sudan in 1985 to that in 1989?
Provide a succinct answer. 2.14. What is the ratio of the Aid received (constant 2012 US$) of Cyprus in 1985 to that in 1990?
Provide a short and direct response. 1.41. What is the ratio of the Aid received (constant 2012 US$) of Equatorial Guinea in 1985 to that in 1990?
Provide a succinct answer. 0.49. What is the ratio of the Aid received (constant 2012 US$) of Sudan in 1985 to that in 1990?
Offer a very short reply. 2.11. What is the ratio of the Aid received (constant 2012 US$) in Cyprus in 1985 to that in 1991?
Offer a terse response. 1.4. What is the ratio of the Aid received (constant 2012 US$) in Equatorial Guinea in 1985 to that in 1991?
Make the answer very short. 0.49. What is the ratio of the Aid received (constant 2012 US$) of Sudan in 1985 to that in 1991?
Provide a succinct answer. 2.12. What is the ratio of the Aid received (constant 2012 US$) in Cyprus in 1985 to that in 1992?
Make the answer very short. 2.22. What is the ratio of the Aid received (constant 2012 US$) of Equatorial Guinea in 1985 to that in 1992?
Your response must be concise. 0.53. What is the ratio of the Aid received (constant 2012 US$) of Sudan in 1985 to that in 1992?
Your response must be concise. 3.63. What is the ratio of the Aid received (constant 2012 US$) in Cyprus in 1986 to that in 1987?
Provide a short and direct response. 0.9. What is the ratio of the Aid received (constant 2012 US$) in Equatorial Guinea in 1986 to that in 1987?
Offer a very short reply. 0.42. What is the ratio of the Aid received (constant 2012 US$) of Sudan in 1986 to that in 1987?
Give a very brief answer. 1.22. What is the ratio of the Aid received (constant 2012 US$) in Cyprus in 1986 to that in 1988?
Give a very brief answer. 0.9. What is the ratio of the Aid received (constant 2012 US$) of Equatorial Guinea in 1986 to that in 1988?
Your answer should be very brief. 0.52. What is the ratio of the Aid received (constant 2012 US$) of Sudan in 1986 to that in 1988?
Provide a short and direct response. 1.24. What is the ratio of the Aid received (constant 2012 US$) of Cyprus in 1986 to that in 1989?
Offer a terse response. 0.99. What is the ratio of the Aid received (constant 2012 US$) in Equatorial Guinea in 1986 to that in 1989?
Give a very brief answer. 0.42. What is the ratio of the Aid received (constant 2012 US$) of Sudan in 1986 to that in 1989?
Your answer should be very brief. 1.54. What is the ratio of the Aid received (constant 2012 US$) in Cyprus in 1986 to that in 1990?
Offer a very short reply. 1.14. What is the ratio of the Aid received (constant 2012 US$) of Equatorial Guinea in 1986 to that in 1990?
Offer a very short reply. 0.47. What is the ratio of the Aid received (constant 2012 US$) in Sudan in 1986 to that in 1990?
Ensure brevity in your answer.  1.51. What is the ratio of the Aid received (constant 2012 US$) in Cyprus in 1986 to that in 1991?
Provide a succinct answer. 1.13. What is the ratio of the Aid received (constant 2012 US$) of Equatorial Guinea in 1986 to that in 1991?
Offer a terse response. 0.47. What is the ratio of the Aid received (constant 2012 US$) of Sudan in 1986 to that in 1991?
Your answer should be very brief. 1.52. What is the ratio of the Aid received (constant 2012 US$) of Cyprus in 1986 to that in 1992?
Offer a very short reply. 1.8. What is the ratio of the Aid received (constant 2012 US$) in Equatorial Guinea in 1986 to that in 1992?
Your answer should be compact. 0.51. What is the ratio of the Aid received (constant 2012 US$) of Sudan in 1986 to that in 1992?
Your answer should be very brief. 2.6. What is the ratio of the Aid received (constant 2012 US$) in Cyprus in 1987 to that in 1988?
Ensure brevity in your answer.  0.99. What is the ratio of the Aid received (constant 2012 US$) in Equatorial Guinea in 1987 to that in 1988?
Give a very brief answer. 1.24. What is the ratio of the Aid received (constant 2012 US$) in Sudan in 1987 to that in 1988?
Keep it short and to the point. 1.02. What is the ratio of the Aid received (constant 2012 US$) in Cyprus in 1987 to that in 1989?
Your answer should be compact. 1.09. What is the ratio of the Aid received (constant 2012 US$) in Sudan in 1987 to that in 1989?
Your answer should be compact. 1.26. What is the ratio of the Aid received (constant 2012 US$) of Cyprus in 1987 to that in 1990?
Offer a very short reply. 1.26. What is the ratio of the Aid received (constant 2012 US$) in Equatorial Guinea in 1987 to that in 1990?
Offer a terse response. 1.12. What is the ratio of the Aid received (constant 2012 US$) in Sudan in 1987 to that in 1990?
Offer a terse response. 1.24. What is the ratio of the Aid received (constant 2012 US$) in Cyprus in 1987 to that in 1991?
Give a very brief answer. 1.25. What is the ratio of the Aid received (constant 2012 US$) of Equatorial Guinea in 1987 to that in 1991?
Ensure brevity in your answer.  1.11. What is the ratio of the Aid received (constant 2012 US$) of Sudan in 1987 to that in 1991?
Your answer should be compact. 1.25. What is the ratio of the Aid received (constant 2012 US$) of Cyprus in 1987 to that in 1992?
Provide a short and direct response. 1.99. What is the ratio of the Aid received (constant 2012 US$) of Equatorial Guinea in 1987 to that in 1992?
Keep it short and to the point. 1.2. What is the ratio of the Aid received (constant 2012 US$) in Sudan in 1987 to that in 1992?
Make the answer very short. 2.13. What is the ratio of the Aid received (constant 2012 US$) in Cyprus in 1988 to that in 1989?
Keep it short and to the point. 1.1. What is the ratio of the Aid received (constant 2012 US$) of Equatorial Guinea in 1988 to that in 1989?
Provide a short and direct response. 0.81. What is the ratio of the Aid received (constant 2012 US$) in Sudan in 1988 to that in 1989?
Give a very brief answer. 1.23. What is the ratio of the Aid received (constant 2012 US$) in Cyprus in 1988 to that in 1990?
Your answer should be very brief. 1.27. What is the ratio of the Aid received (constant 2012 US$) in Equatorial Guinea in 1988 to that in 1990?
Make the answer very short. 0.9. What is the ratio of the Aid received (constant 2012 US$) in Sudan in 1988 to that in 1990?
Make the answer very short. 1.22. What is the ratio of the Aid received (constant 2012 US$) of Cyprus in 1988 to that in 1991?
Your answer should be very brief. 1.26. What is the ratio of the Aid received (constant 2012 US$) of Equatorial Guinea in 1988 to that in 1991?
Your answer should be very brief. 0.9. What is the ratio of the Aid received (constant 2012 US$) of Sudan in 1988 to that in 1991?
Your response must be concise. 1.22. What is the ratio of the Aid received (constant 2012 US$) of Cyprus in 1988 to that in 1992?
Make the answer very short. 2. What is the ratio of the Aid received (constant 2012 US$) in Equatorial Guinea in 1988 to that in 1992?
Offer a terse response. 0.97. What is the ratio of the Aid received (constant 2012 US$) of Sudan in 1988 to that in 1992?
Offer a terse response. 2.09. What is the ratio of the Aid received (constant 2012 US$) in Cyprus in 1989 to that in 1990?
Provide a succinct answer. 1.15. What is the ratio of the Aid received (constant 2012 US$) of Equatorial Guinea in 1989 to that in 1990?
Make the answer very short. 1.11. What is the ratio of the Aid received (constant 2012 US$) in Sudan in 1989 to that in 1990?
Your answer should be very brief. 0.99. What is the ratio of the Aid received (constant 2012 US$) of Cyprus in 1989 to that in 1991?
Ensure brevity in your answer.  1.15. What is the ratio of the Aid received (constant 2012 US$) in Equatorial Guinea in 1989 to that in 1991?
Your answer should be compact. 1.1. What is the ratio of the Aid received (constant 2012 US$) in Cyprus in 1989 to that in 1992?
Give a very brief answer. 1.82. What is the ratio of the Aid received (constant 2012 US$) of Equatorial Guinea in 1989 to that in 1992?
Your answer should be very brief. 1.19. What is the ratio of the Aid received (constant 2012 US$) in Sudan in 1989 to that in 1992?
Offer a very short reply. 1.69. What is the ratio of the Aid received (constant 2012 US$) in Sudan in 1990 to that in 1991?
Your answer should be very brief. 1.01. What is the ratio of the Aid received (constant 2012 US$) in Cyprus in 1990 to that in 1992?
Give a very brief answer. 1.58. What is the ratio of the Aid received (constant 2012 US$) in Equatorial Guinea in 1990 to that in 1992?
Make the answer very short. 1.07. What is the ratio of the Aid received (constant 2012 US$) of Sudan in 1990 to that in 1992?
Give a very brief answer. 1.72. What is the ratio of the Aid received (constant 2012 US$) in Cyprus in 1991 to that in 1992?
Keep it short and to the point. 1.59. What is the ratio of the Aid received (constant 2012 US$) in Equatorial Guinea in 1991 to that in 1992?
Give a very brief answer. 1.08. What is the ratio of the Aid received (constant 2012 US$) of Sudan in 1991 to that in 1992?
Your response must be concise. 1.71. What is the difference between the highest and the second highest Aid received (constant 2012 US$) in Cyprus?
Your response must be concise. 8.47e+06. What is the difference between the highest and the second highest Aid received (constant 2012 US$) of Equatorial Guinea?
Your answer should be compact. 6.80e+05. What is the difference between the highest and the second highest Aid received (constant 2012 US$) in Sudan?
Make the answer very short. 8.01e+08. What is the difference between the highest and the lowest Aid received (constant 2012 US$) in Cyprus?
Give a very brief answer. 4.67e+07. What is the difference between the highest and the lowest Aid received (constant 2012 US$) in Equatorial Guinea?
Keep it short and to the point. 6.11e+07. What is the difference between the highest and the lowest Aid received (constant 2012 US$) in Sudan?
Provide a short and direct response. 2.05e+09. 